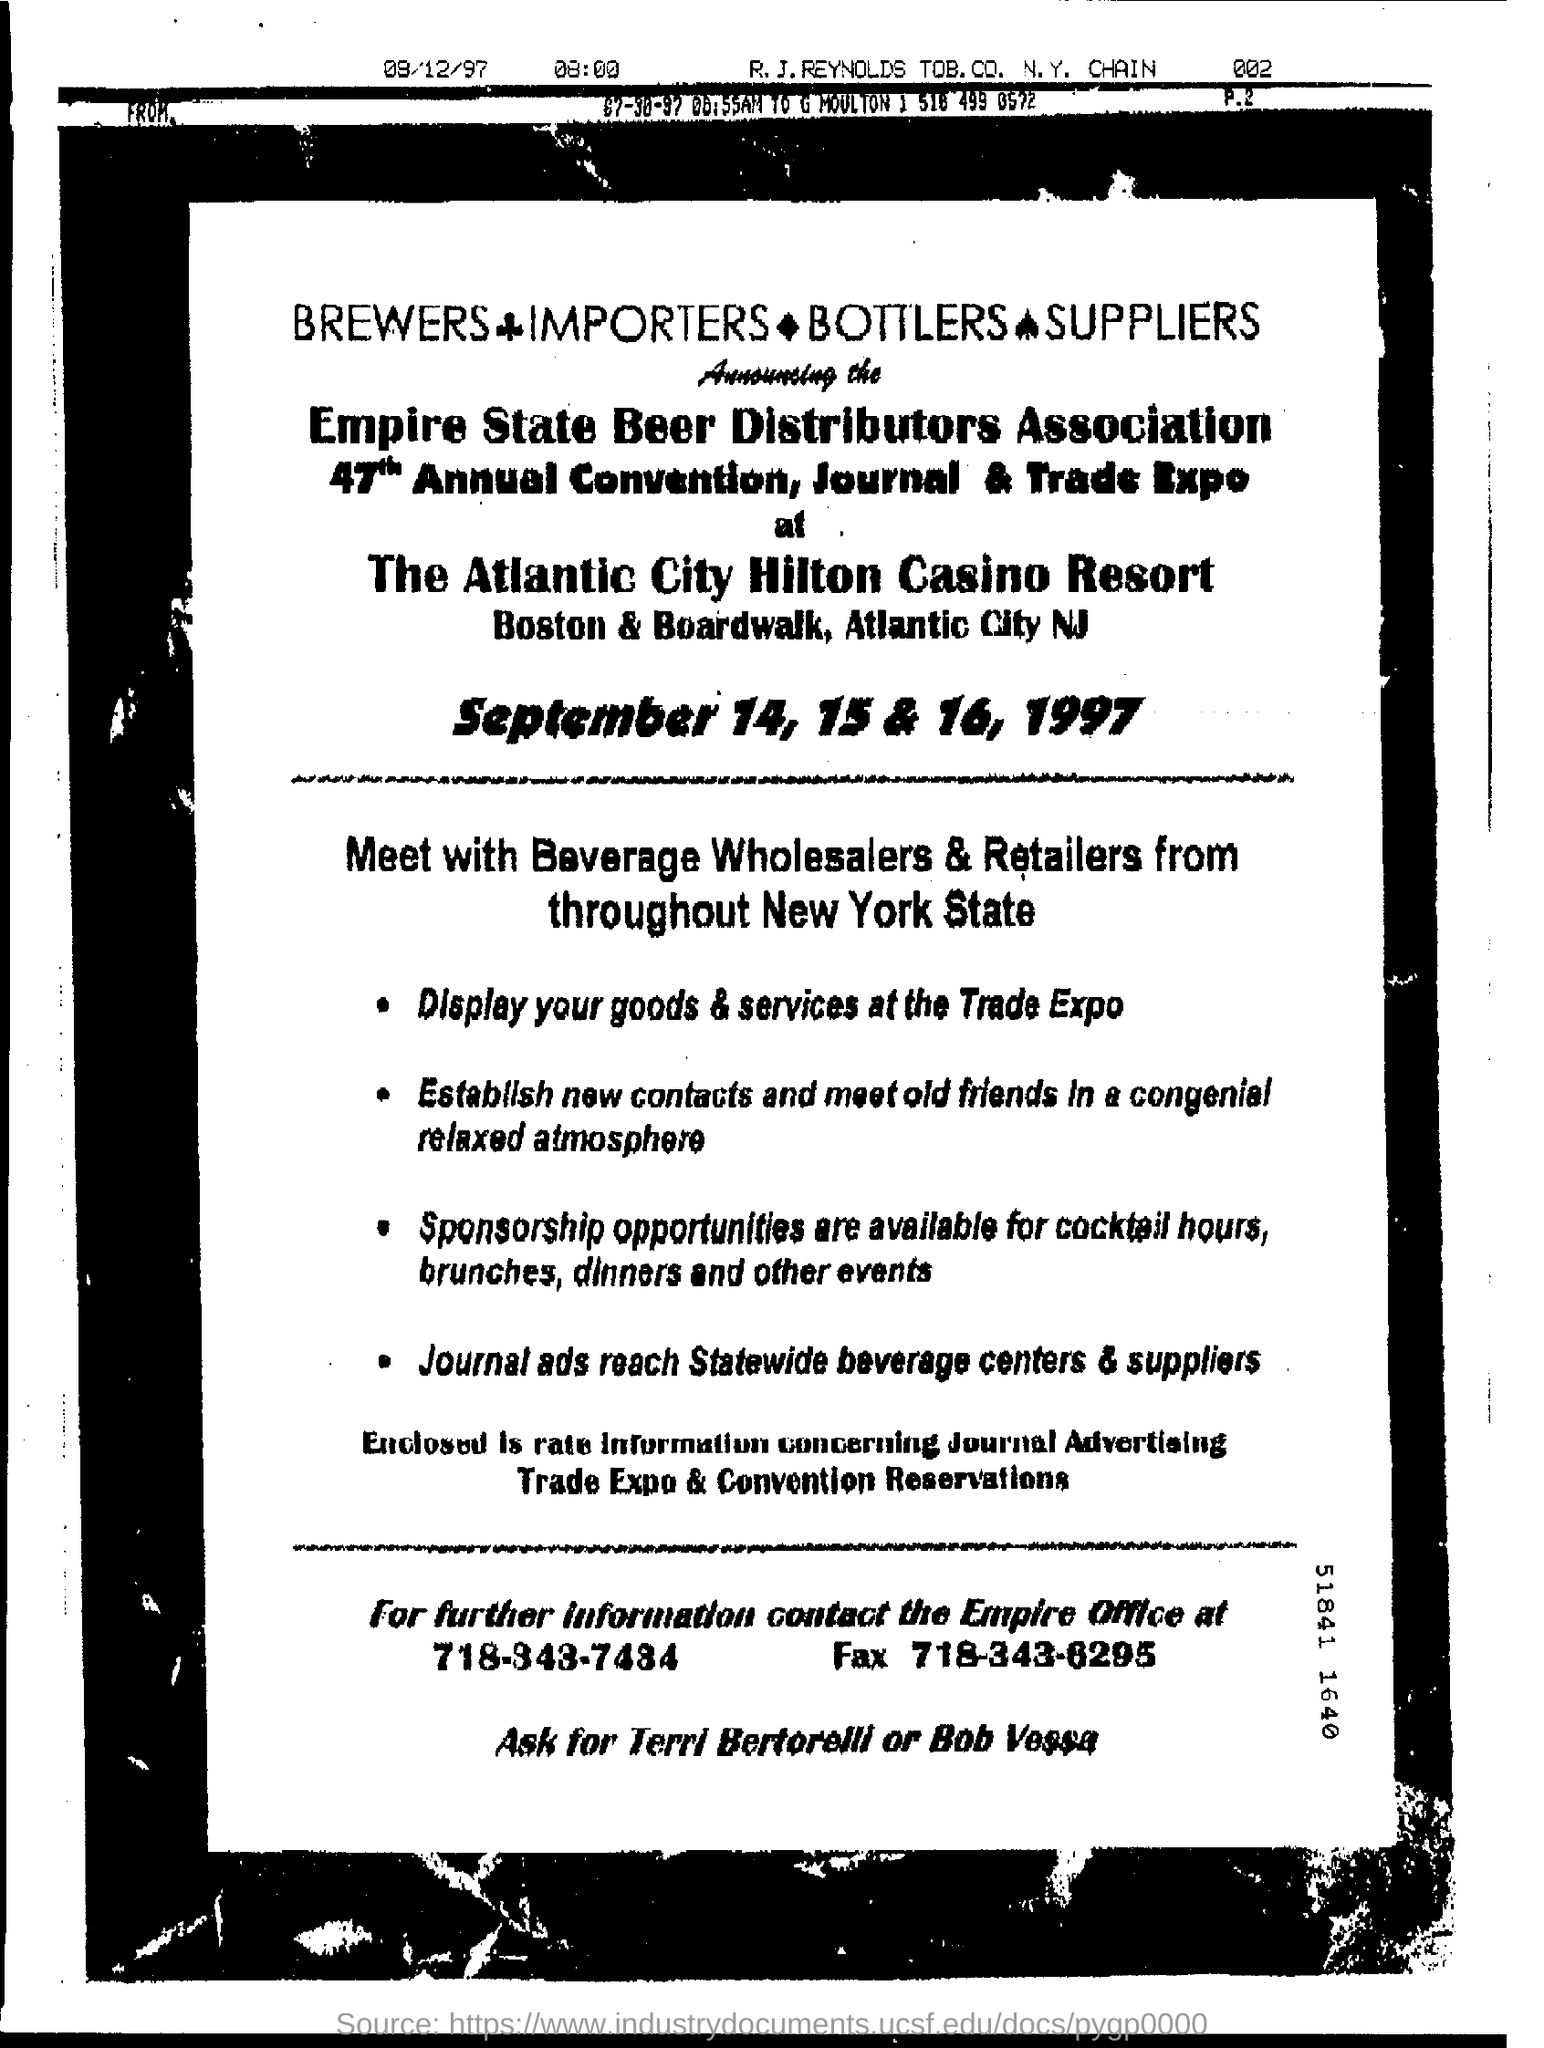Draw attention to some important aspects in this diagram. The convention will take place on September 14, 15, and 16, 1997. The event occurred on September 14, 15, and 16 of the year 1997. The individuals to be contacted for further information are Terri Bertorelli and Bob Vessa. 